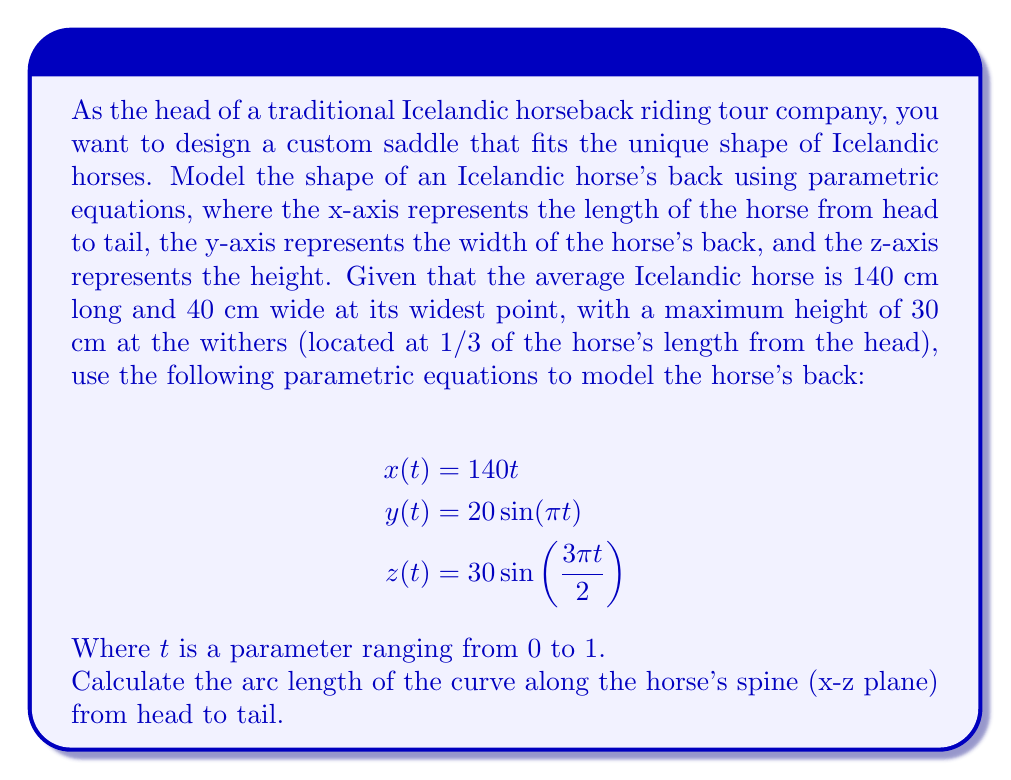Show me your answer to this math problem. To calculate the arc length of the curve along the horse's spine, we need to focus on the x-z plane, as this represents the side view of the horse. We'll use the arc length formula for parametric curves:

$$L = \int_a^b \sqrt{\left(\frac{dx}{dt}\right)^2 + \left(\frac{dz}{dt}\right)^2} dt$$

Step 1: Calculate the derivatives
$$\frac{dx}{dt} = 140$$
$$\frac{dz}{dt} = 30 \cdot \frac{3\pi}{2} \cos(\frac{3\pi t}{2}) = 45\pi \cos(\frac{3\pi t}{2})$$

Step 2: Substitute into the arc length formula
$$L = \int_0^1 \sqrt{140^2 + (45\pi \cos(\frac{3\pi t}{2}))^2} dt$$

Step 3: Simplify the expression under the square root
$$L = \int_0^1 \sqrt{19600 + 2025\pi^2 \cos^2(\frac{3\pi t}{2})} dt$$

Step 4: This integral cannot be solved analytically, so we need to use numerical integration methods. Using a computer algebra system or numerical integration tool, we can approximate the result:

$$L \approx 143.8 \text{ cm}$$

This result makes sense, as it's slightly longer than the straight-line length of 140 cm due to the curvature of the horse's back.
Answer: $143.8 \text{ cm}$ 